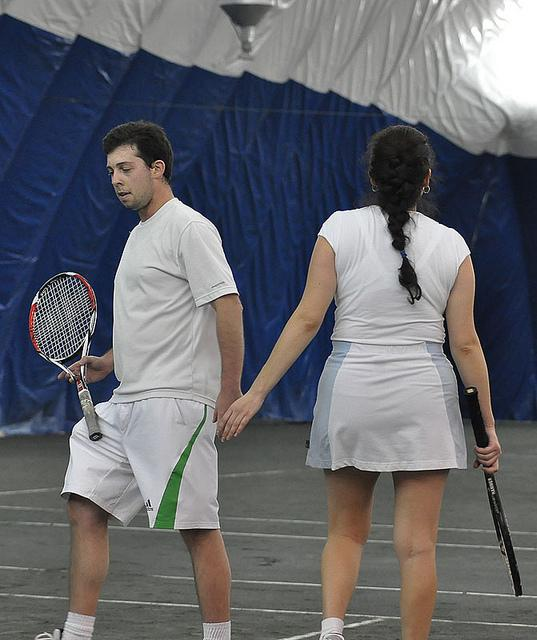What is making the man's pocket pop up? tennis ball 